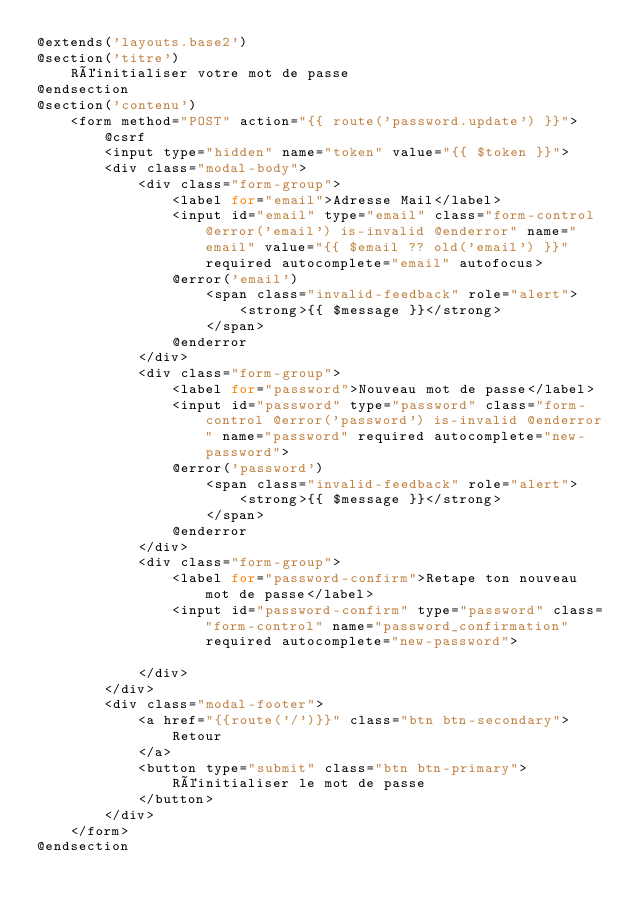<code> <loc_0><loc_0><loc_500><loc_500><_PHP_>@extends('layouts.base2')
@section('titre')
    Réinitialiser votre mot de passe
@endsection
@section('contenu')
    <form method="POST" action="{{ route('password.update') }}">
        @csrf
        <input type="hidden" name="token" value="{{ $token }}">
        <div class="modal-body">
            <div class="form-group">
                <label for="email">Adresse Mail</label>
                <input id="email" type="email" class="form-control @error('email') is-invalid @enderror" name="email" value="{{ $email ?? old('email') }}" required autocomplete="email" autofocus>
                @error('email')
                    <span class="invalid-feedback" role="alert">
                        <strong>{{ $message }}</strong>
                    </span>
                @enderror            
            </div>
            <div class="form-group">
                <label for="password">Nouveau mot de passe</label>
                <input id="password" type="password" class="form-control @error('password') is-invalid @enderror" name="password" required autocomplete="new-password">
                @error('password')
                    <span class="invalid-feedback" role="alert">
                        <strong>{{ $message }}</strong>
                    </span>
                @enderror
            </div>
            <div class="form-group">
                <label for="password-confirm">Retape ton nouveau mot de passe</label>
                <input id="password-confirm" type="password" class="form-control" name="password_confirmation" required autocomplete="new-password">
                
            </div>    
        </div>
        <div class="modal-footer">
            <a href="{{route('/')}}" class="btn btn-secondary">
                Retour
            </a>
            <button type="submit" class="btn btn-primary">
                Réinitialiser le mot de passe
            </button>
        </div>
    </form>
@endsection</code> 